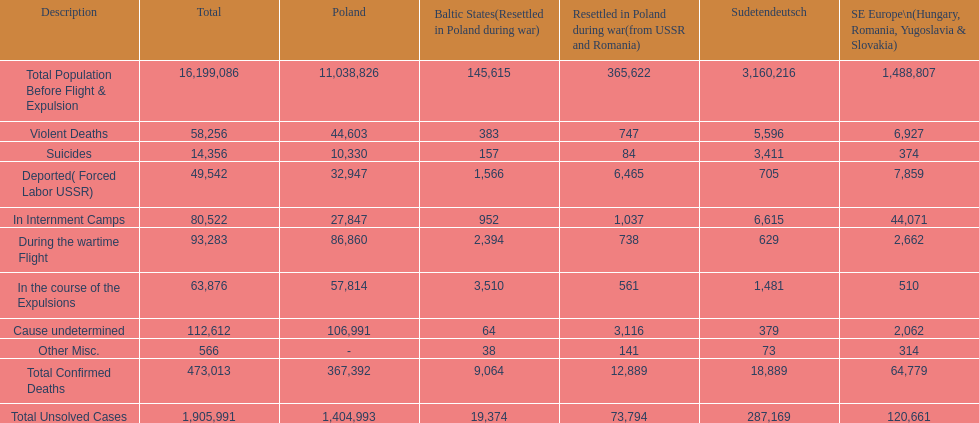What is the distinction between suicides in poland and sudetendeutsch? 6919. 